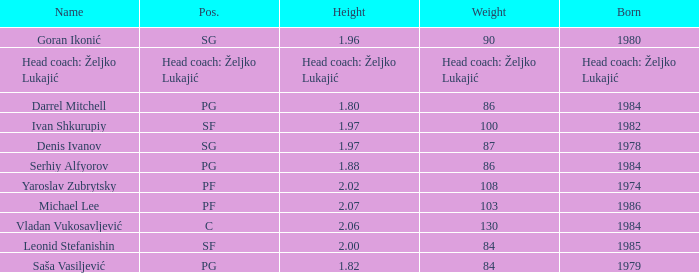What is the weight of the player with a height of 2.00m? 84.0. 